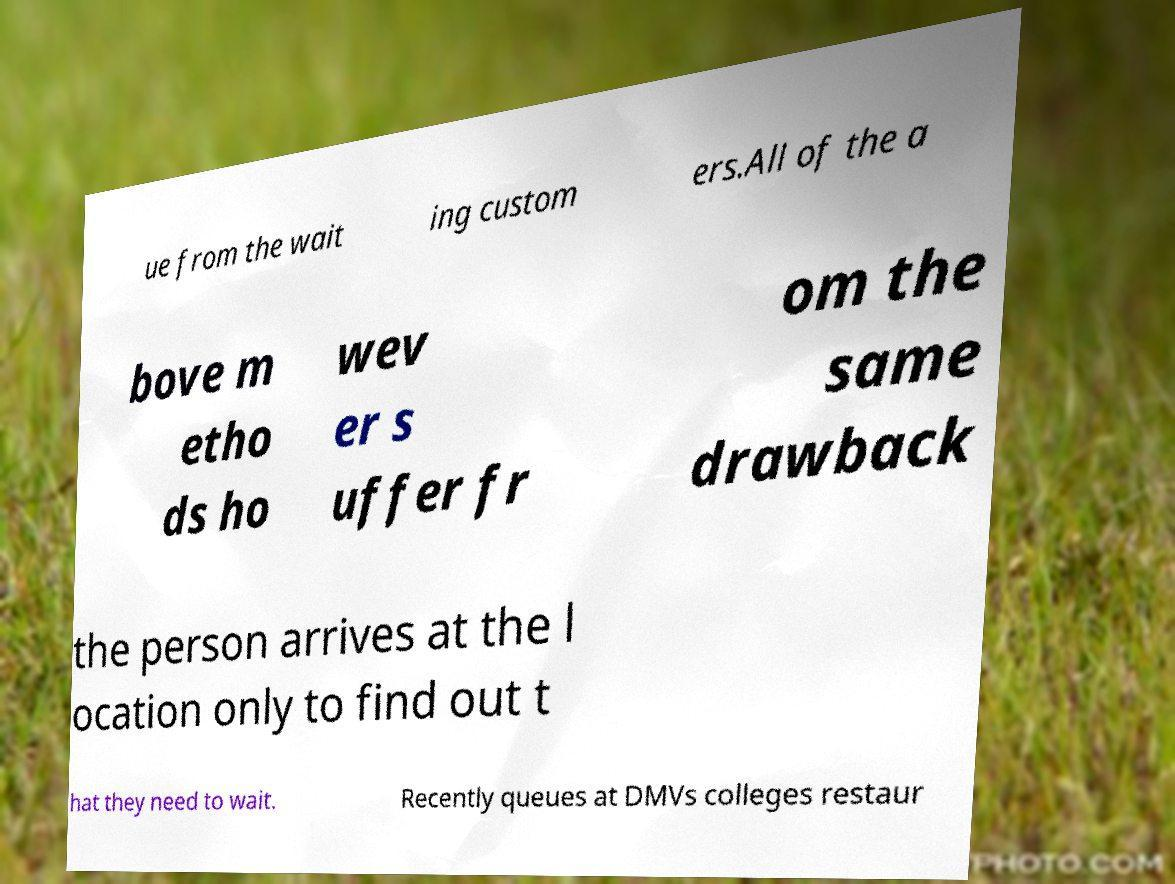For documentation purposes, I need the text within this image transcribed. Could you provide that? ue from the wait ing custom ers.All of the a bove m etho ds ho wev er s uffer fr om the same drawback the person arrives at the l ocation only to find out t hat they need to wait. Recently queues at DMVs colleges restaur 